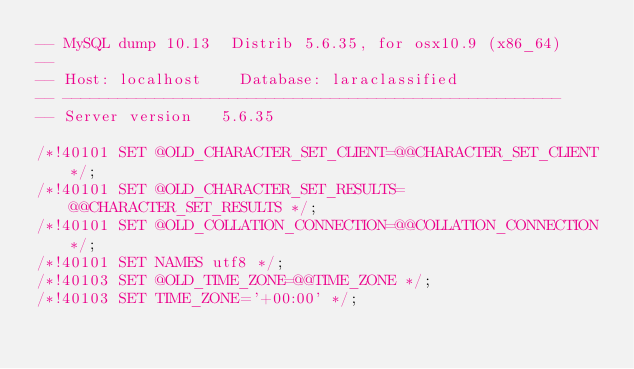<code> <loc_0><loc_0><loc_500><loc_500><_SQL_>-- MySQL dump 10.13  Distrib 5.6.35, for osx10.9 (x86_64)
--
-- Host: localhost    Database: laraclassified
-- ------------------------------------------------------
-- Server version	5.6.35

/*!40101 SET @OLD_CHARACTER_SET_CLIENT=@@CHARACTER_SET_CLIENT */;
/*!40101 SET @OLD_CHARACTER_SET_RESULTS=@@CHARACTER_SET_RESULTS */;
/*!40101 SET @OLD_COLLATION_CONNECTION=@@COLLATION_CONNECTION */;
/*!40101 SET NAMES utf8 */;
/*!40103 SET @OLD_TIME_ZONE=@@TIME_ZONE */;
/*!40103 SET TIME_ZONE='+00:00' */;</code> 